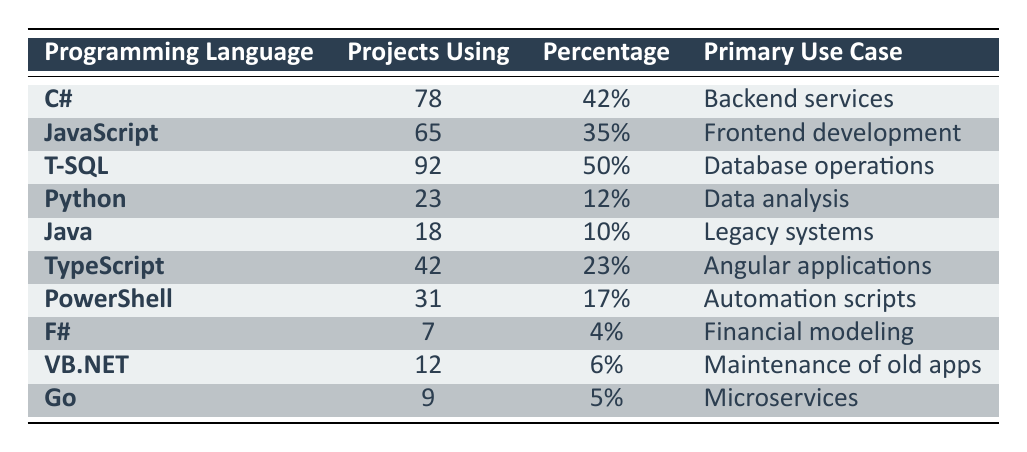What is the programming language used in the most projects? By scanning the "Projects Using" column, T-SQL has the highest count at 92 projects, which is more than any other programming language listed.
Answer: T-SQL How many projects use JavaScript? The table shows that JavaScript is used in 65 projects as indicated in the "Projects Using" column.
Answer: 65 Which programming language has the lowest percentage of projects using it? Looking at the "Percentage" column, F# shows a usage of 4%, which is the lowest compared to other languages.
Answer: F# What is the total number of projects using C# and Python combined? Adding the values from the "Projects Using" column, C# (78) + Python (23) = 101. Therefore, the total number of projects using both is 101.
Answer: 101 Is T-SQL the primary programming language for automation scripts? In the "Primary Use Case" column, T-SQL is associated with database operations whereas PowerShell is mentioned for automation scripts, making this statement false.
Answer: No Which language is primarily used for frontend development? The table indicates that JavaScript is the primary programming language for frontend development, specified under "Primary Use Case."
Answer: JavaScript What percentage of projects utilize TypeScript? Referring to the "Percentage" column, TypeScript is noted to be used in 23% of projects.
Answer: 23% What is the median percentage of usage for all programming languages listed? First, we must note the percentages: 42, 35, 50, 12, 10, 23, 17, 4, 6, 5. Sorted, these values are 4, 5, 6, 10, 12, 17, 23, 35, 42, and 50. There are 10 values, so the median will be the average of the 5th (12) and 6th (17) values. The median is (12 + 17) / 2 = 14.5.
Answer: 14.5 How many programming languages have a usage percentage of 20% or higher? The percentages that are 20% or more are: C# (42%), JavaScript (35%), T-SQL (50%), and TypeScript (23%). This totals to four programming languages.
Answer: 4 Is Go used more than Java? Examining the "Projects Using" column, Go is used in 9 projects while Java is used in 18 projects, hence Go is not used more than Java.
Answer: No 